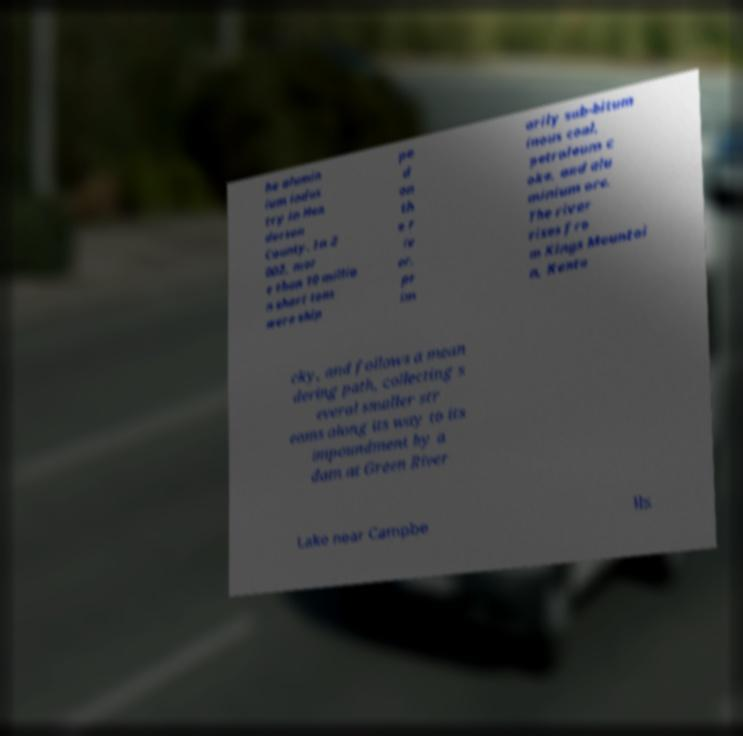For documentation purposes, I need the text within this image transcribed. Could you provide that? he alumin ium indus try in Hen derson County. In 2 002, mor e than 10 millio n short tons were ship pe d on th e r iv er, pr im arily sub-bitum inous coal, petroleum c oke, and alu minium ore. The river rises fro m Kings Mountai n, Kentu cky, and follows a mean dering path, collecting s everal smaller str eams along its way to its impoundment by a dam at Green River Lake near Campbe lls 